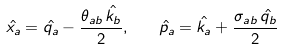<formula> <loc_0><loc_0><loc_500><loc_500>\hat { x _ { a } } = \hat { q _ { a } } - \frac { \theta _ { a b } \, \hat { k _ { b } } } { 2 } , \quad \hat { p _ { a } } = \hat { k _ { a } } + \frac { \sigma _ { a b } \, \hat { q _ { b } } } { 2 }</formula> 